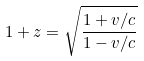Convert formula to latex. <formula><loc_0><loc_0><loc_500><loc_500>1 + z = { \sqrt { \frac { 1 + v / c } { 1 - v / c } } }</formula> 